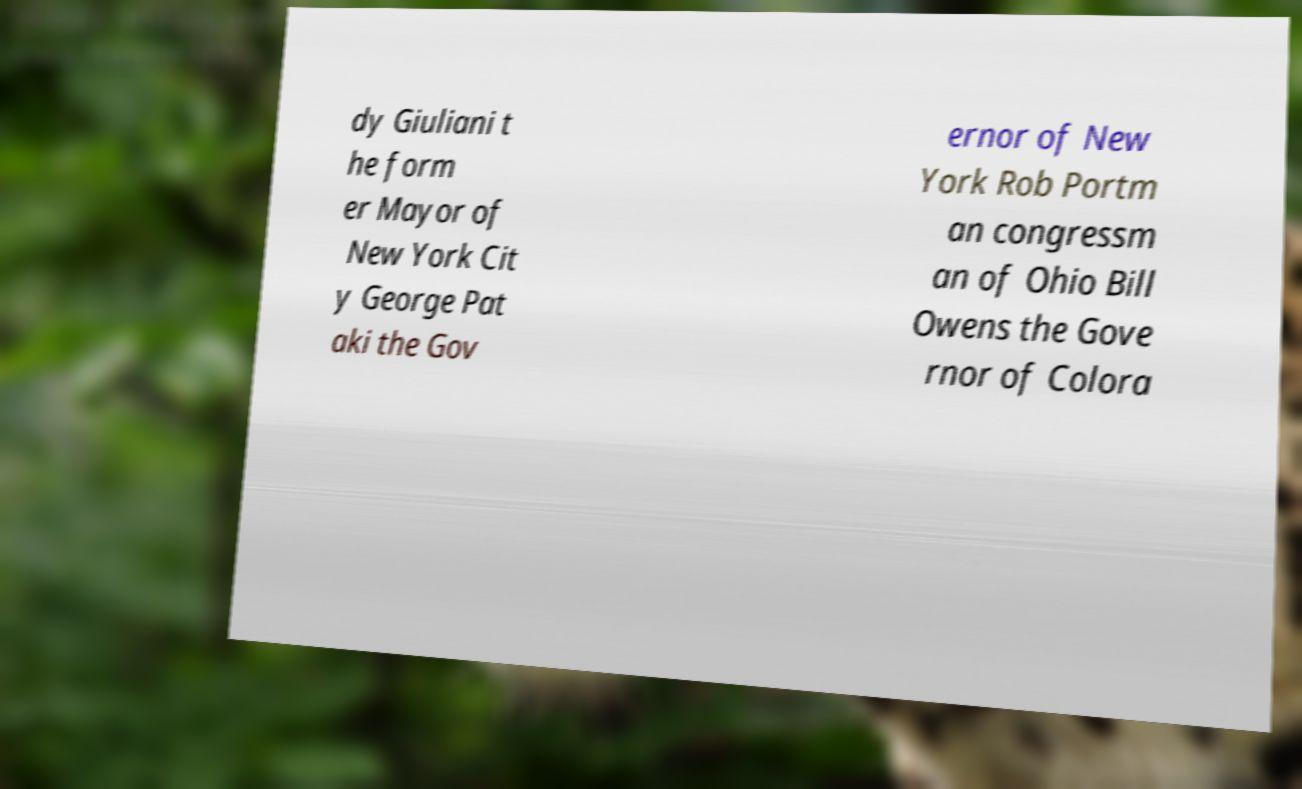Please read and relay the text visible in this image. What does it say? dy Giuliani t he form er Mayor of New York Cit y George Pat aki the Gov ernor of New York Rob Portm an congressm an of Ohio Bill Owens the Gove rnor of Colora 